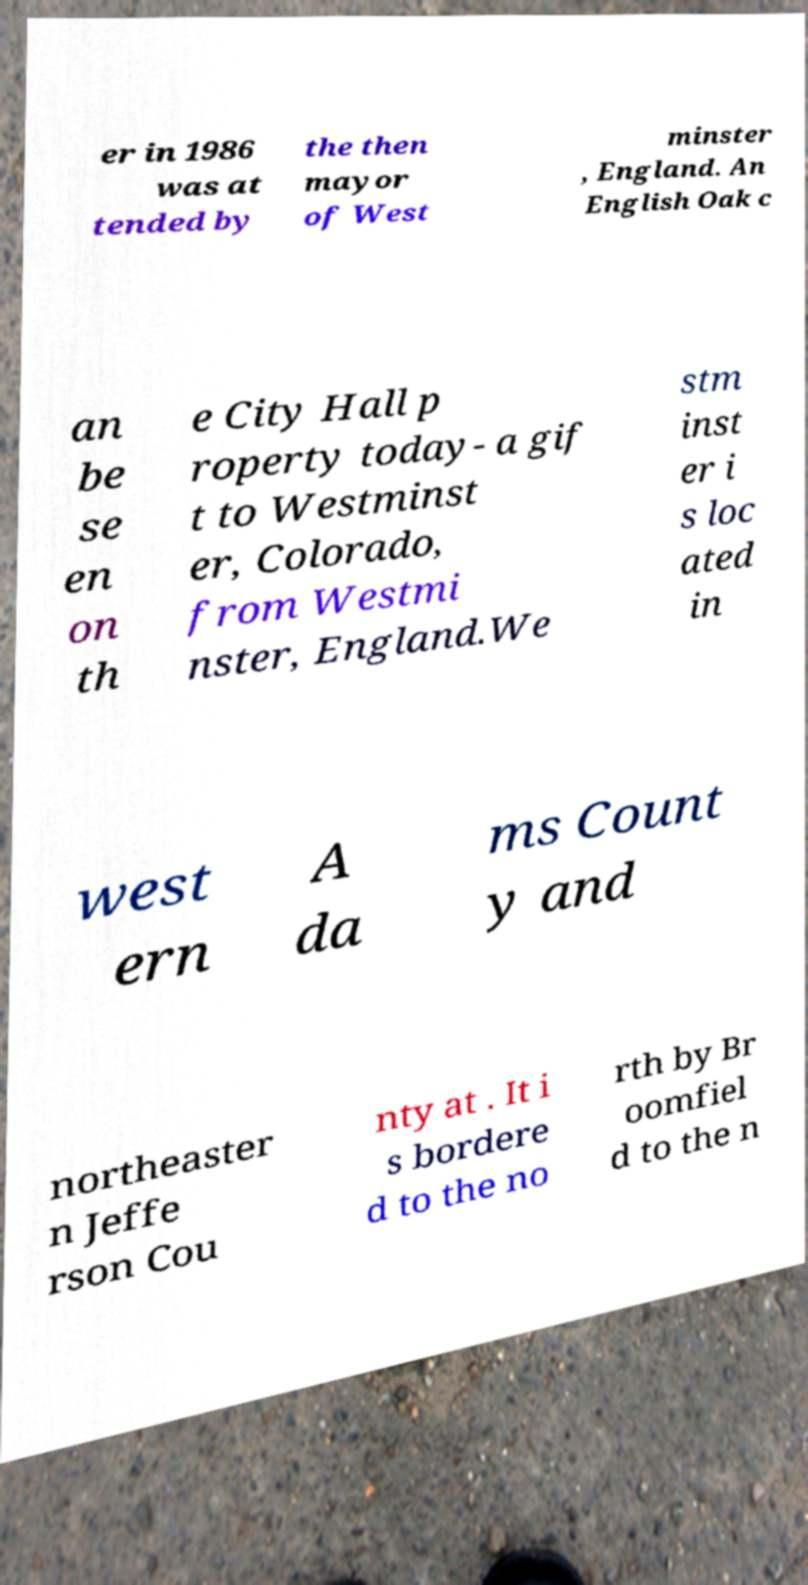Please read and relay the text visible in this image. What does it say? er in 1986 was at tended by the then mayor of West minster , England. An English Oak c an be se en on th e City Hall p roperty today- a gif t to Westminst er, Colorado, from Westmi nster, England.We stm inst er i s loc ated in west ern A da ms Count y and northeaster n Jeffe rson Cou nty at . It i s bordere d to the no rth by Br oomfiel d to the n 